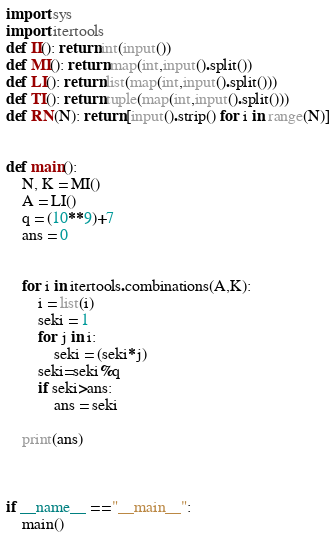Convert code to text. <code><loc_0><loc_0><loc_500><loc_500><_Python_>import sys
import itertools
def II(): return int(input())
def MI(): return map(int,input().split())
def LI(): return list(map(int,input().split()))
def TI(): return tuple(map(int,input().split()))
def RN(N): return [input().strip() for i in range(N)]


def main():
    N, K = MI()
    A = LI()
    q = (10**9)+7
    ans = 0


    for i in itertools.combinations(A,K):
        i = list(i)
        seki = 1
        for j in i:
            seki = (seki*j)
        seki=seki%q
        if seki>ans:
            ans = seki

    print(ans)

    

if __name__ == "__main__":
	main()</code> 